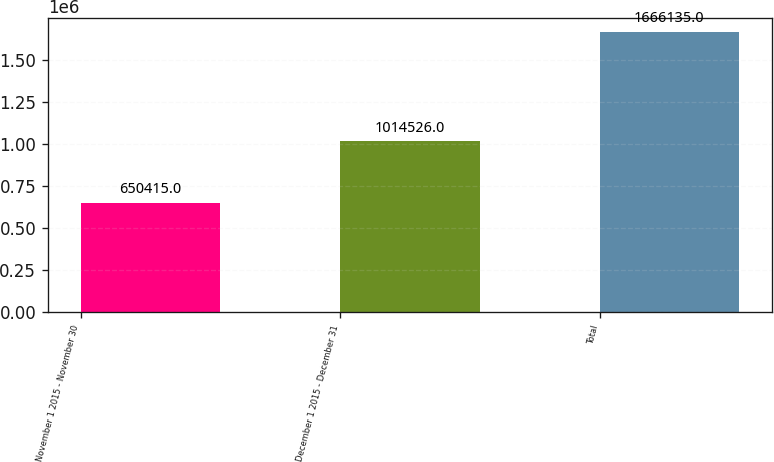Convert chart. <chart><loc_0><loc_0><loc_500><loc_500><bar_chart><fcel>November 1 2015 - November 30<fcel>December 1 2015 - December 31<fcel>Total<nl><fcel>650415<fcel>1.01453e+06<fcel>1.66614e+06<nl></chart> 